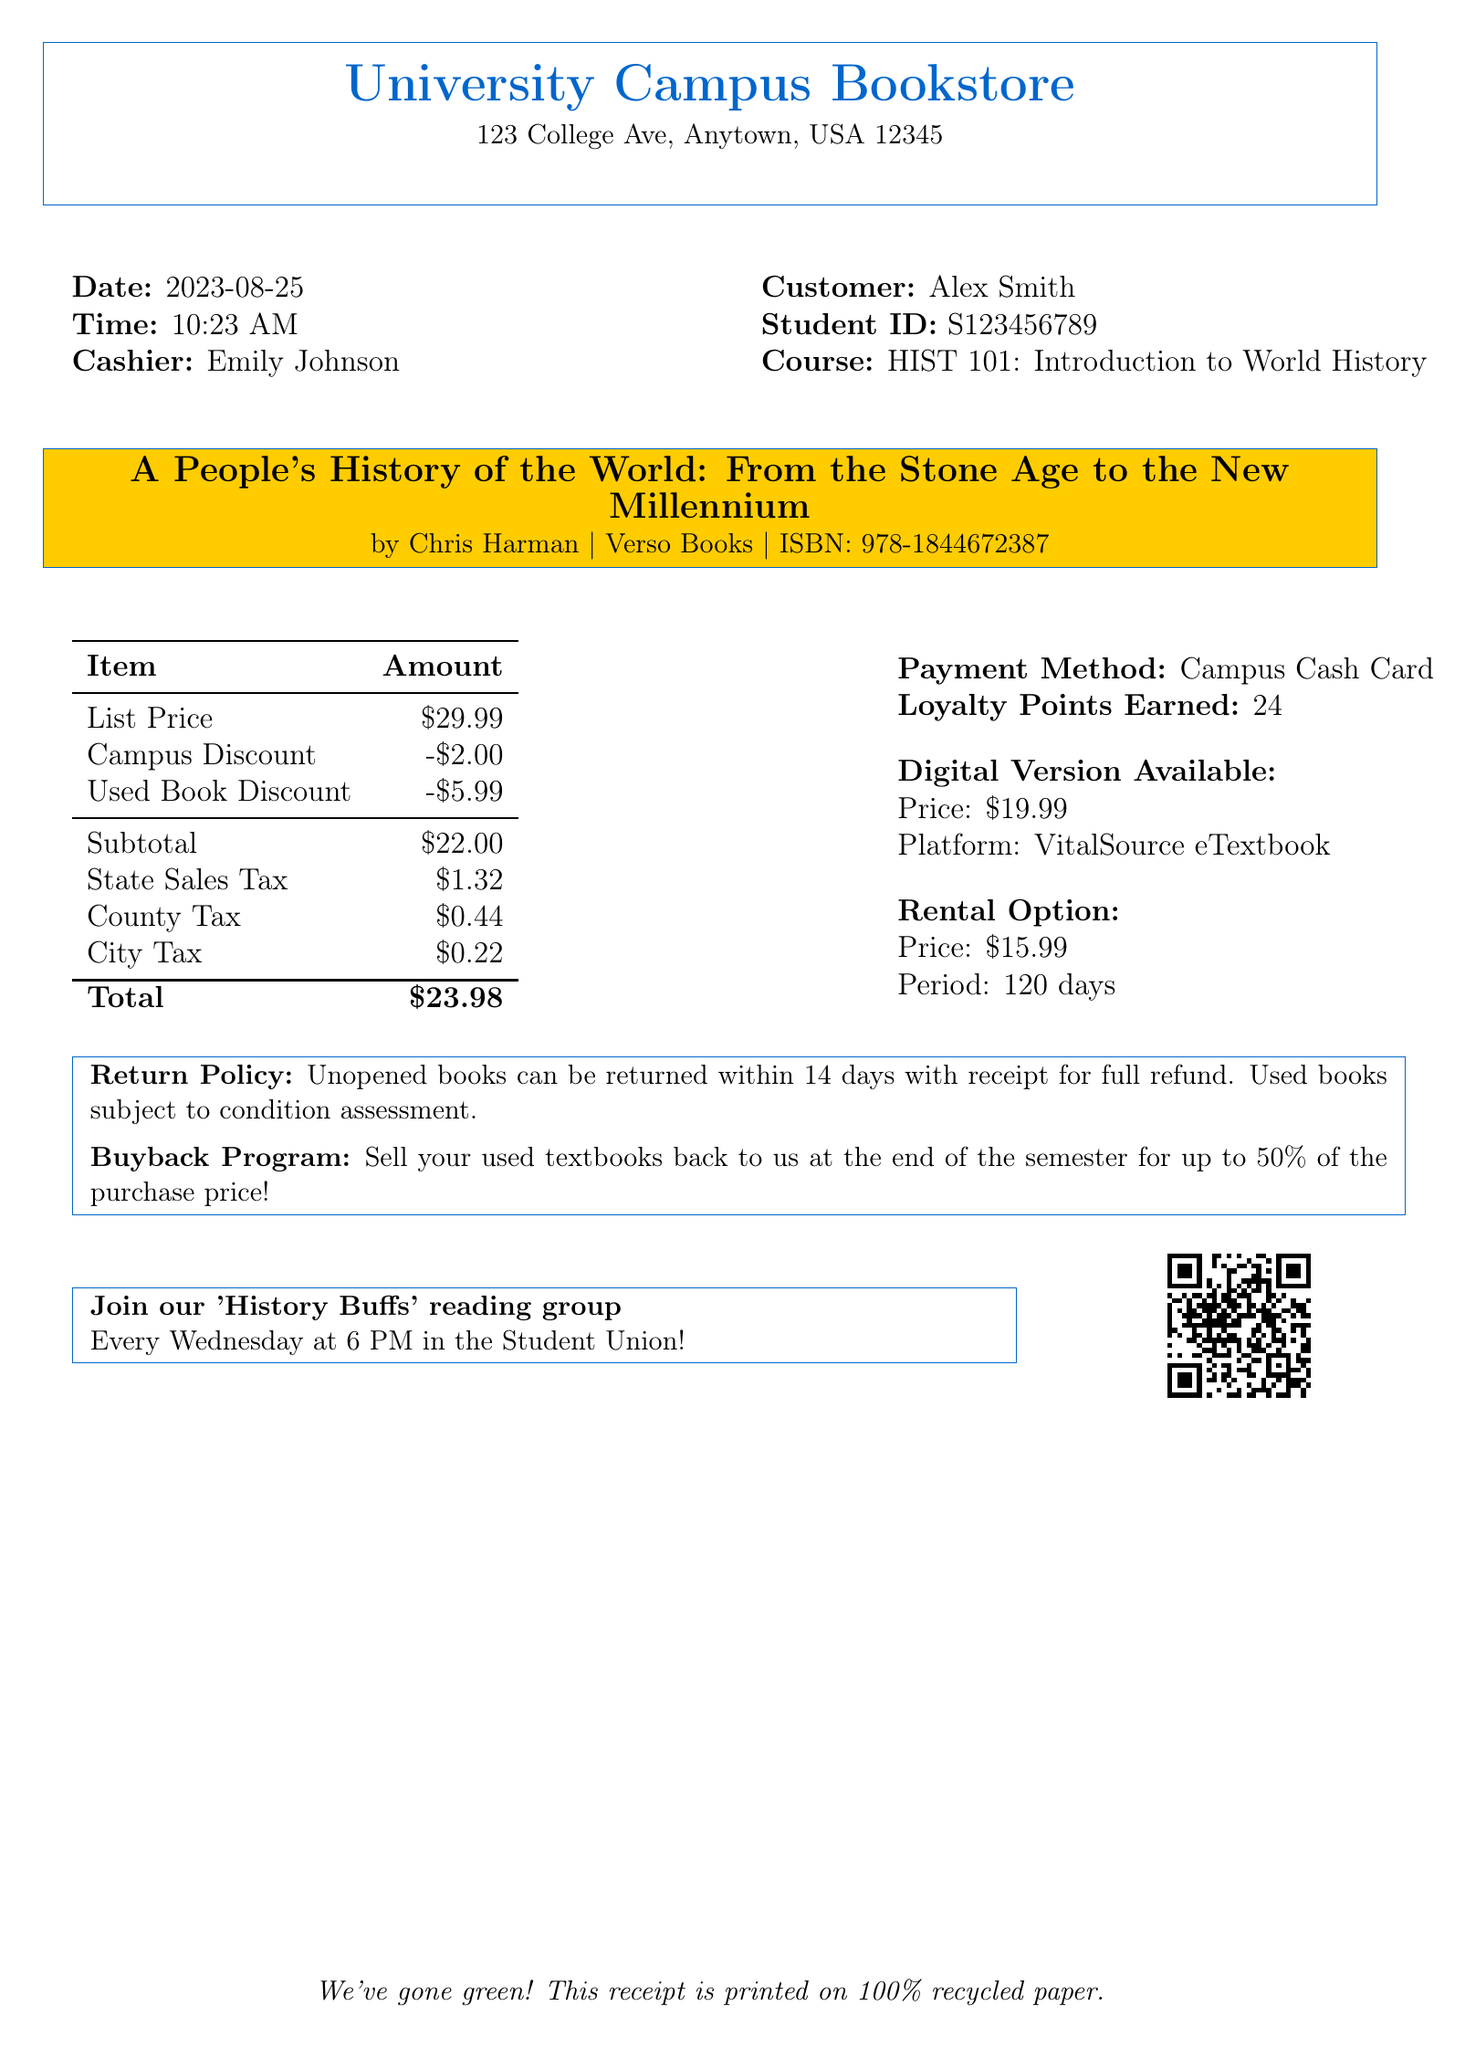What is the name of the textbook? The textbook title is listed in the document as "A People's History of the World: From the Stone Age to the New Millennium."
Answer: A People's History of the World: From the Stone Age to the New Millennium Who is the author of the textbook? The author of the textbook is provided in the document under the textbook details.
Answer: Chris Harman What is the transaction date? The date of the transaction is specified within the document.
Answer: 2023-08-25 How much was the campus discount? The amount of the campus discount is given in the pricing section of the document.
Answer: $2.00 What is the subtotal before taxes? The subtotal amount is listed prior to the taxes section in the document.
Answer: $22.00 What are the total taxes applied? The total amount of taxes is the sum of the state sales tax, county tax, and city tax listed in the document.
Answer: $2.98 What payment method was used for this transaction? The payment method is mentioned in the transaction document.
Answer: Campus Cash Card How many loyalty points were earned? The document lists the loyalty points earned from this transaction.
Answer: 24 What is the rental price for the textbook? The rental price for the textbook is provided as an option in the document.
Answer: $15.99 What is the return policy for unopened books? The document states the return policy for unopened books clearly.
Answer: Unopened books can be returned within 14 days with receipt for full refund 